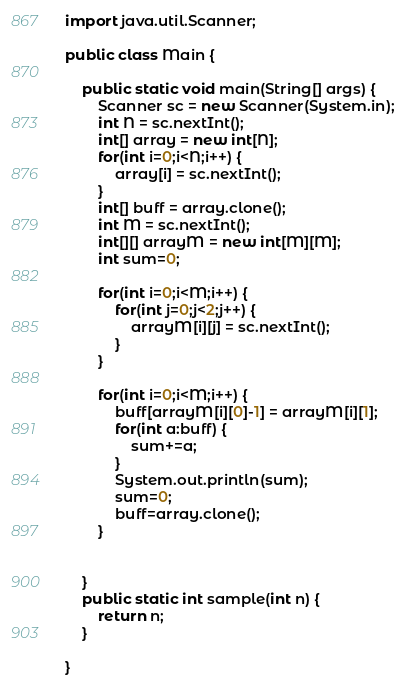<code> <loc_0><loc_0><loc_500><loc_500><_Java_>import java.util.Scanner;

public class Main {

	public static void main(String[] args) {
		Scanner sc = new Scanner(System.in);
		int N = sc.nextInt();
		int[] array = new int[N];
		for(int i=0;i<N;i++) {
			array[i] = sc.nextInt();
		}
		int[] buff = array.clone();
		int M = sc.nextInt();
		int[][] arrayM = new int[M][M];
		int sum=0;

		for(int i=0;i<M;i++) {
			for(int j=0;j<2;j++) {
				arrayM[i][j] = sc.nextInt();
			}
		}

		for(int i=0;i<M;i++) {
			buff[arrayM[i][0]-1] = arrayM[i][1];
			for(int a:buff) {
				sum+=a;
			}
			System.out.println(sum);
			sum=0;
			buff=array.clone();
		}


	}
	public static int sample(int n) {
		return n;
	}

}
</code> 